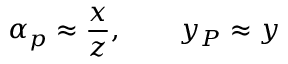Convert formula to latex. <formula><loc_0><loc_0><loc_500><loc_500>\alpha _ { p } \approx \frac { x } { z } , \quad y _ { P } \approx y</formula> 